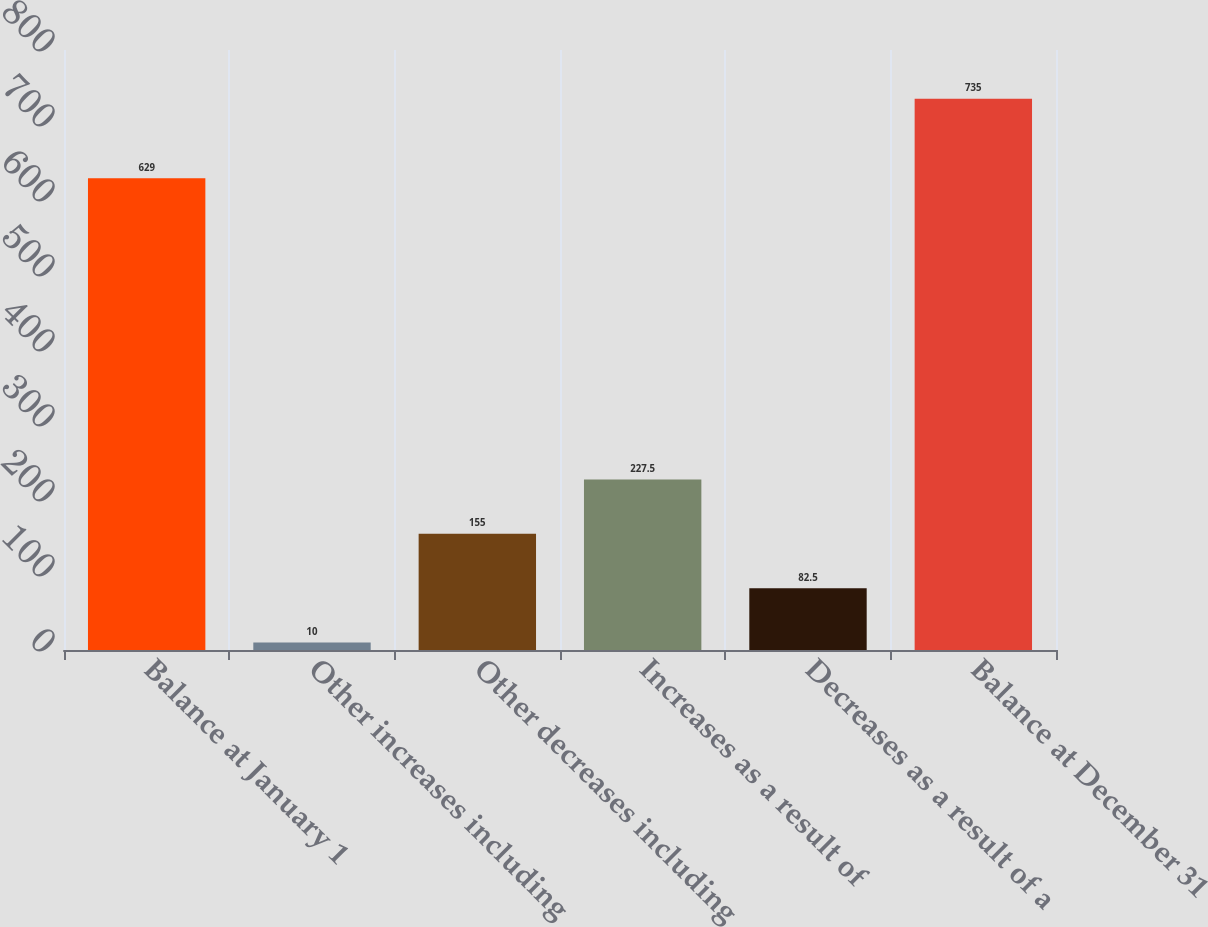Convert chart to OTSL. <chart><loc_0><loc_0><loc_500><loc_500><bar_chart><fcel>Balance at January 1<fcel>Other increases including<fcel>Other decreases including<fcel>Increases as a result of<fcel>Decreases as a result of a<fcel>Balance at December 31<nl><fcel>629<fcel>10<fcel>155<fcel>227.5<fcel>82.5<fcel>735<nl></chart> 